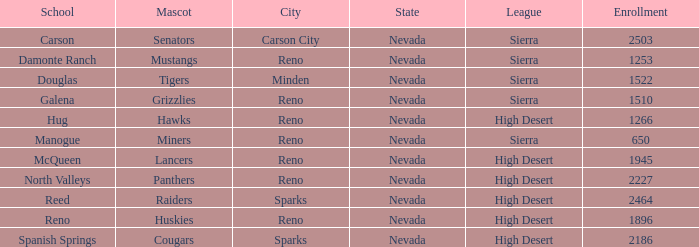Which leagues is the Galena school in? Sierra. I'm looking to parse the entire table for insights. Could you assist me with that? {'header': ['School', 'Mascot', 'City', 'State', 'League', 'Enrollment'], 'rows': [['Carson', 'Senators', 'Carson City', 'Nevada', 'Sierra', '2503'], ['Damonte Ranch', 'Mustangs', 'Reno', 'Nevada', 'Sierra', '1253'], ['Douglas', 'Tigers', 'Minden', 'Nevada', 'Sierra', '1522'], ['Galena', 'Grizzlies', 'Reno', 'Nevada', 'Sierra', '1510'], ['Hug', 'Hawks', 'Reno', 'Nevada', 'High Desert', '1266'], ['Manogue', 'Miners', 'Reno', 'Nevada', 'Sierra', '650'], ['McQueen', 'Lancers', 'Reno', 'Nevada', 'High Desert', '1945'], ['North Valleys', 'Panthers', 'Reno', 'Nevada', 'High Desert', '2227'], ['Reed', 'Raiders', 'Sparks', 'Nevada', 'High Desert', '2464'], ['Reno', 'Huskies', 'Reno', 'Nevada', 'High Desert', '1896'], ['Spanish Springs', 'Cougars', 'Sparks', 'Nevada', 'High Desert', '2186']]} 